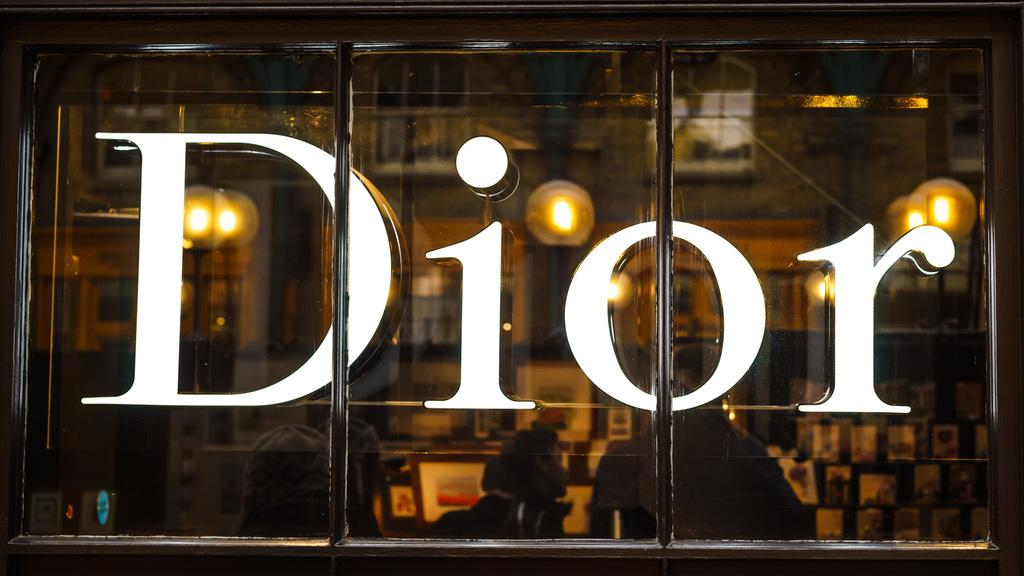What is written or displayed on the glass in the image? There are letters in white color on the glass. What can be seen illuminated in the image? There are lights visible in the image. How many people are present in the image? There are few persons in the image. What type of objects are present in the image that might hold pictures or artwork? There are frames in the image. What type of disease is being treated in the image? There is no indication of a disease or medical treatment in the image. What is being served for breakfast in the image? There is no reference to breakfast or food in the image. 